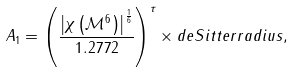Convert formula to latex. <formula><loc_0><loc_0><loc_500><loc_500>A _ { 1 } = \left ( \frac { \left | \chi \left ( \mathcal { M } ^ { 6 } \right ) \right | ^ { \frac { 1 } { 6 } } } { 1 . 2 7 7 2 } \right ) ^ { \tau } \times d e S i t t e r r a d i u s ,</formula> 